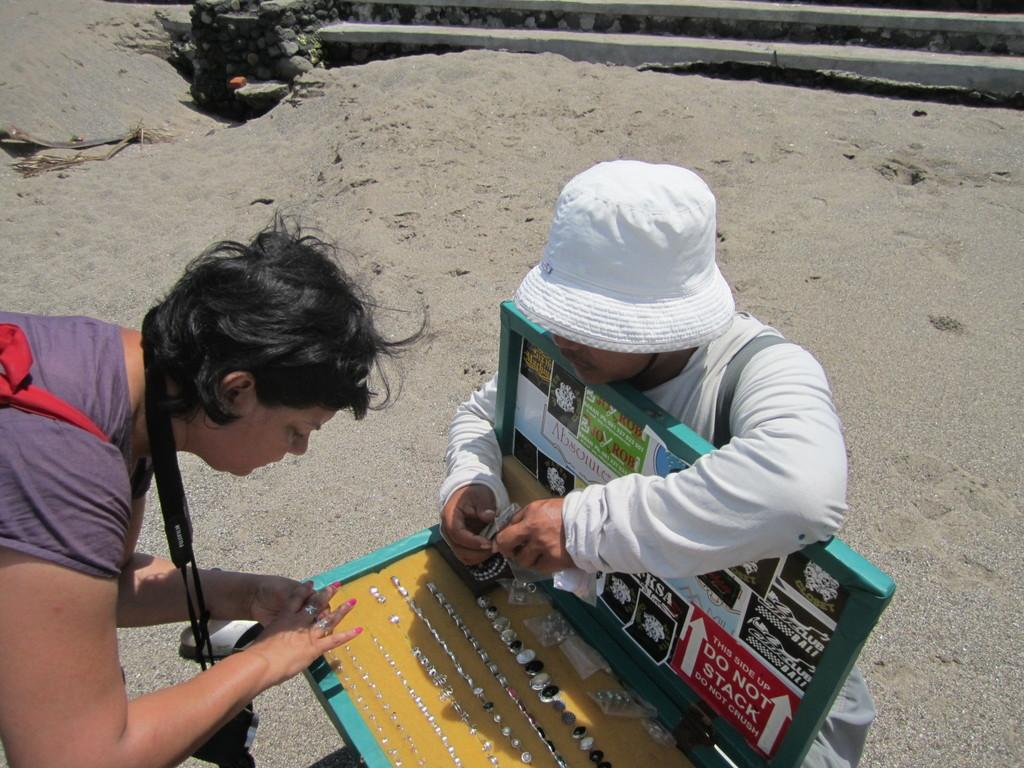How many people are in the image? There are two persons in the image. What is the box containing in the image? The box contains finger rings arranged in an order. What can be seen in the background of the image? There is a wall and sand in the background of the image. What page of the book is the brother reading in the image? There is no book or brother present in the image. What attraction is visible in the background of the image? There is no attraction visible in the image; it only features a wall and sand in the background. 